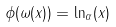Convert formula to latex. <formula><loc_0><loc_0><loc_500><loc_500>\phi ( \omega ( x ) ) = \ln _ { \alpha } ( x )</formula> 